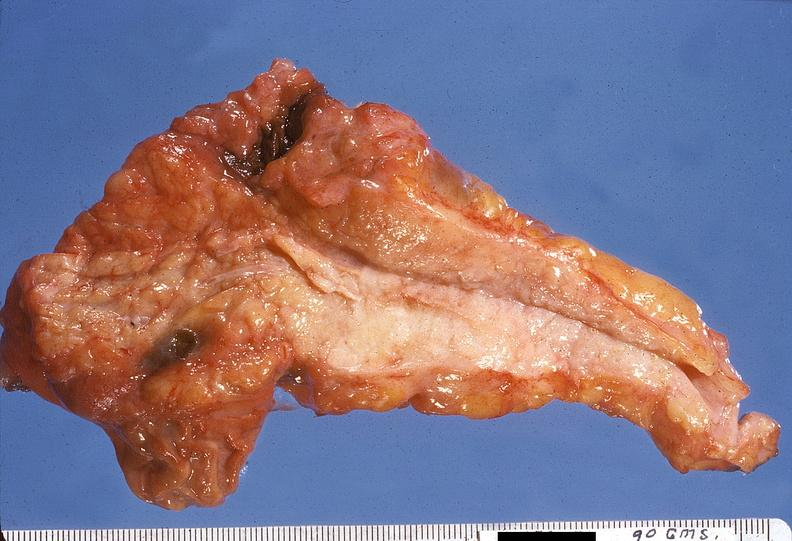does this image show adenocarcinoma, body of pancreas?
Answer the question using a single word or phrase. Yes 